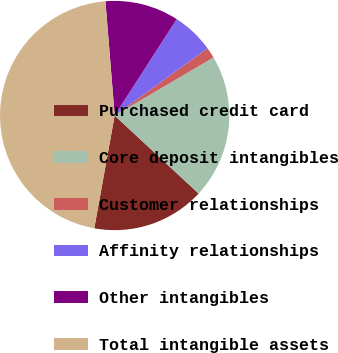<chart> <loc_0><loc_0><loc_500><loc_500><pie_chart><fcel>Purchased credit card<fcel>Core deposit intangibles<fcel>Customer relationships<fcel>Affinity relationships<fcel>Other intangibles<fcel>Total intangible assets<nl><fcel>15.93%<fcel>20.37%<fcel>1.51%<fcel>5.94%<fcel>10.38%<fcel>45.87%<nl></chart> 